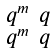<formula> <loc_0><loc_0><loc_500><loc_500>\begin{smallmatrix} q ^ { m } & q \\ q ^ { m } & q \end{smallmatrix}</formula> 